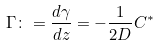Convert formula to latex. <formula><loc_0><loc_0><loc_500><loc_500>\Gamma \colon = \frac { d \gamma } { d z } = - \frac { 1 } { 2 { D } } C ^ { * }</formula> 